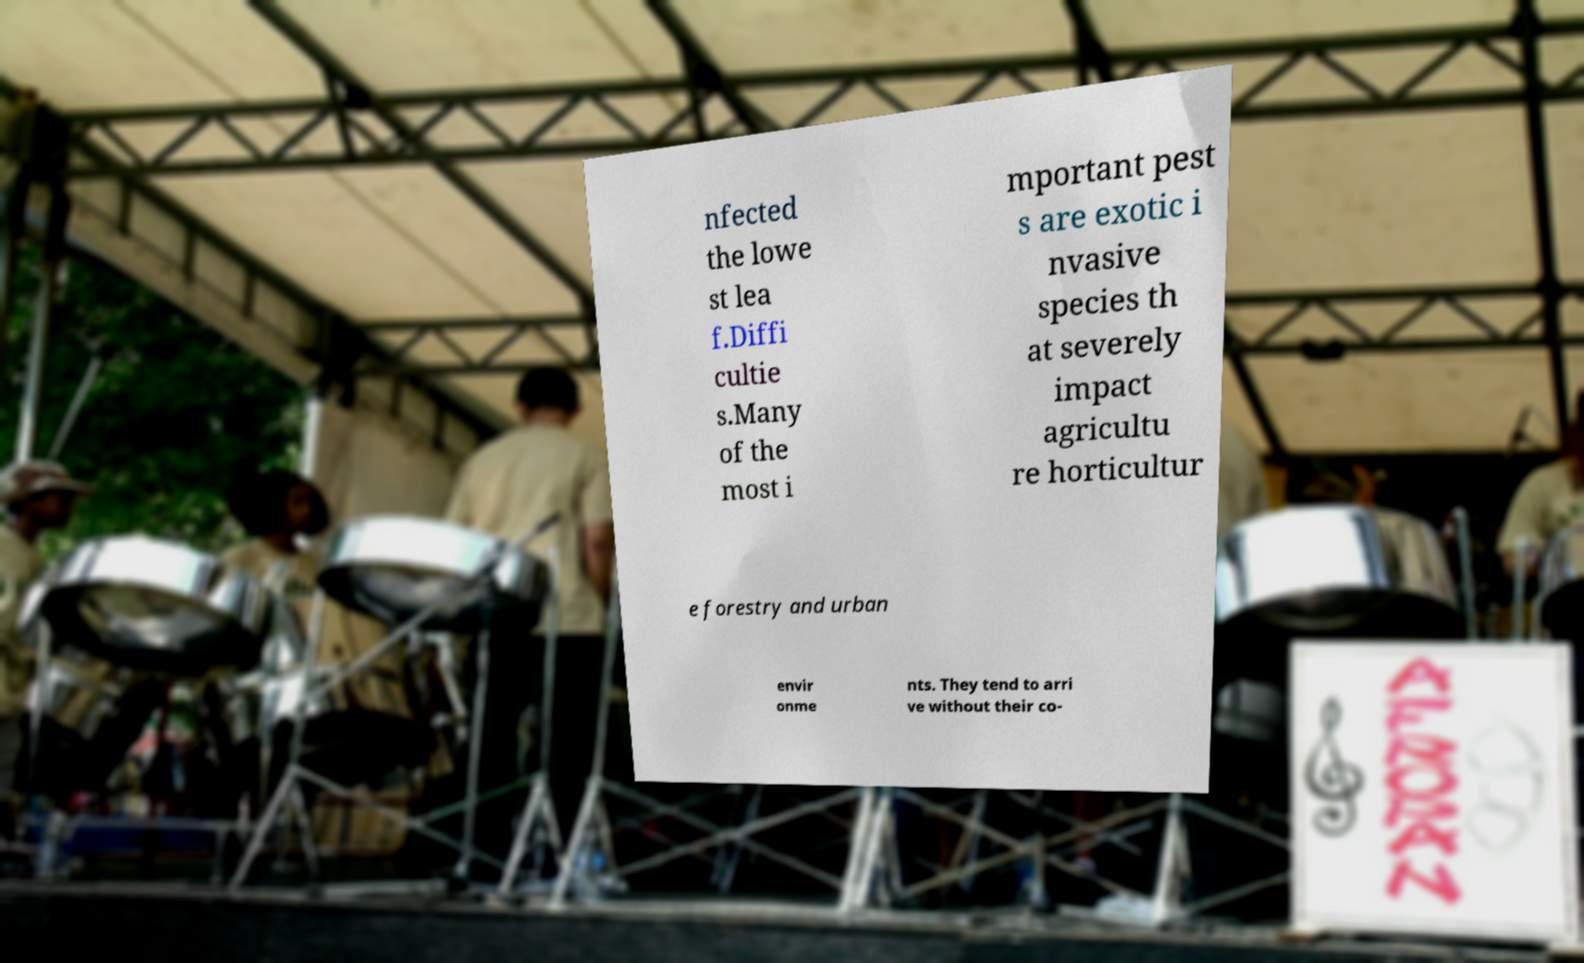Please read and relay the text visible in this image. What does it say? nfected the lowe st lea f.Diffi cultie s.Many of the most i mportant pest s are exotic i nvasive species th at severely impact agricultu re horticultur e forestry and urban envir onme nts. They tend to arri ve without their co- 